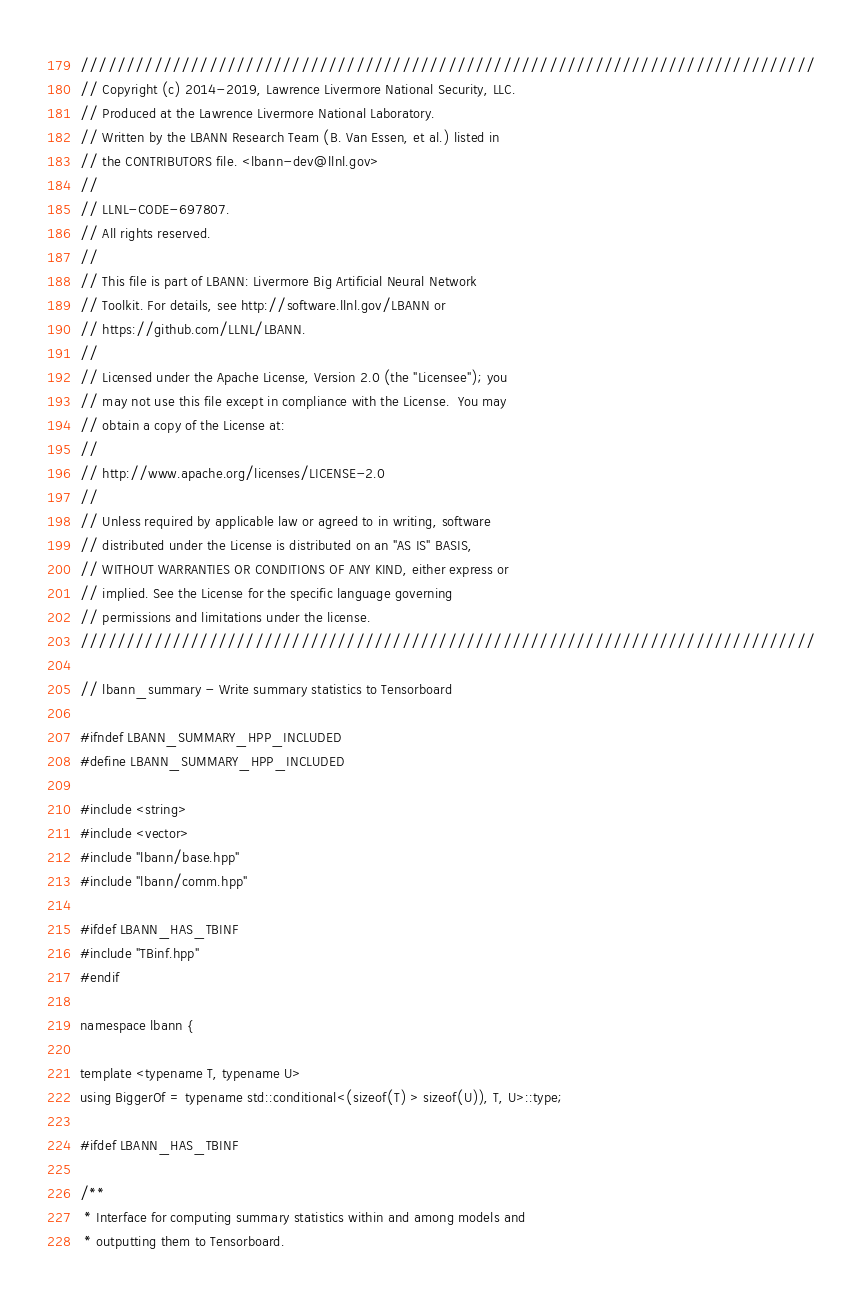<code> <loc_0><loc_0><loc_500><loc_500><_C++_>////////////////////////////////////////////////////////////////////////////////
// Copyright (c) 2014-2019, Lawrence Livermore National Security, LLC.
// Produced at the Lawrence Livermore National Laboratory.
// Written by the LBANN Research Team (B. Van Essen, et al.) listed in
// the CONTRIBUTORS file. <lbann-dev@llnl.gov>
//
// LLNL-CODE-697807.
// All rights reserved.
//
// This file is part of LBANN: Livermore Big Artificial Neural Network
// Toolkit. For details, see http://software.llnl.gov/LBANN or
// https://github.com/LLNL/LBANN.
//
// Licensed under the Apache License, Version 2.0 (the "Licensee"); you
// may not use this file except in compliance with the License.  You may
// obtain a copy of the License at:
//
// http://www.apache.org/licenses/LICENSE-2.0
//
// Unless required by applicable law or agreed to in writing, software
// distributed under the License is distributed on an "AS IS" BASIS,
// WITHOUT WARRANTIES OR CONDITIONS OF ANY KIND, either express or
// implied. See the License for the specific language governing
// permissions and limitations under the license.
////////////////////////////////////////////////////////////////////////////////

// lbann_summary - Write summary statistics to Tensorboard

#ifndef LBANN_SUMMARY_HPP_INCLUDED
#define LBANN_SUMMARY_HPP_INCLUDED

#include <string>
#include <vector>
#include "lbann/base.hpp"
#include "lbann/comm.hpp"

#ifdef LBANN_HAS_TBINF
#include "TBinf.hpp"
#endif

namespace lbann {

template <typename T, typename U>
using BiggerOf = typename std::conditional<(sizeof(T) > sizeof(U)), T, U>::type;

#ifdef LBANN_HAS_TBINF

/**
 * Interface for computing summary statistics within and among models and
 * outputting them to Tensorboard.</code> 